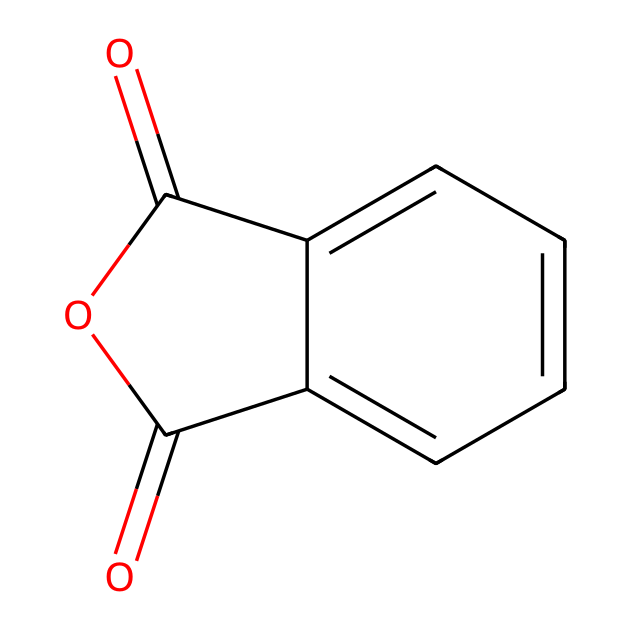What is the molecular formula of phthalic anhydride? By analyzing the structure denoted by the SMILES notation, which indicates the presence of carbon (C), oxygen (O), and hydrogen (H) in a specific arrangement, we can derive its formula. Counting the carbons gives us 8 (C) and 4 oxygens (O), and since it is an anhydride, we deduce that there are also 4 hydrogens (H) associated with the structure. Therefore, the overall molecular formula can be represented as C8H4O3.
Answer: C8H4O3 How many rings are present in this structure? The structure indicated by the SMILES notation shows a fused bicyclic system with two interlinked rings. To determine this, we identify the connections between the carbons in the rings based on the visual representation of the structure, confirming there are two rings in total.
Answer: 2 What type of functional groups are present in phthalic anhydride? By examining the molecular structure, we see the presence of an anhydride linkage formed from the carboxylic acid groups, which indicates the presence of functional groups along with the aromatic ring system. The carbonyl (C=O) and cyclic ester groups are indicative of this. Thus, the primary functional groups are carbonyl and anhydride.
Answer: carbonyl and anhydride What is the total number of atoms in phthalic anhydride? To determine the total atom count, we count all constituent atoms: there are 8 carbons, 4 hydrogens, and 3 oxygens. Adding these quantities together yields a total of 15 atoms in the structure.
Answer: 15 Is phthalic anhydride soluble in water? Given phthalic anhydride's structure as an aromatic compound with an anhydride functional group, it exhibits hydrophobic properties due to the extended aromatic ring system. Typical anhydrides display low solubility, especially in polar solvents like water. This leads to the conclusion that phthalic anhydride is generally considered insoluble in water.
Answer: insoluble 